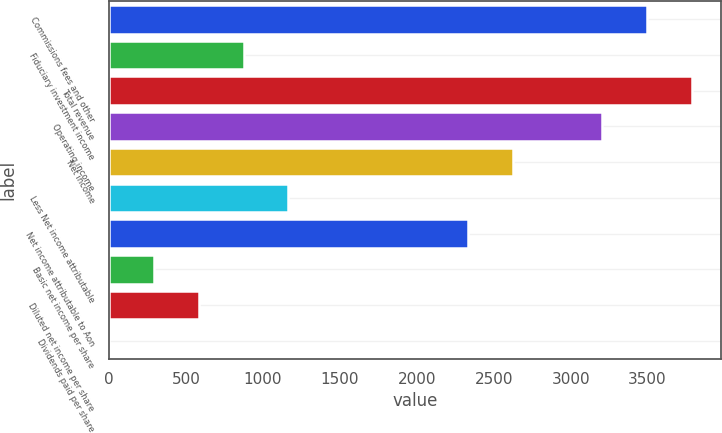Convert chart. <chart><loc_0><loc_0><loc_500><loc_500><bar_chart><fcel>Commissions fees and other<fcel>Fiduciary investment income<fcel>Total revenue<fcel>Operating income<fcel>Net income<fcel>Less Net income attributable<fcel>Net income attributable to Aon<fcel>Basic net income per share<fcel>Diluted net income per share<fcel>Dividends paid per share<nl><fcel>3497.92<fcel>874.6<fcel>3789.4<fcel>3206.44<fcel>2623.48<fcel>1166.08<fcel>2332<fcel>291.64<fcel>583.12<fcel>0.16<nl></chart> 